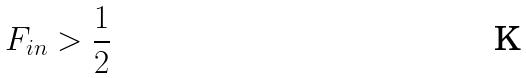<formula> <loc_0><loc_0><loc_500><loc_500>F _ { i n } > \frac { 1 } { 2 }</formula> 